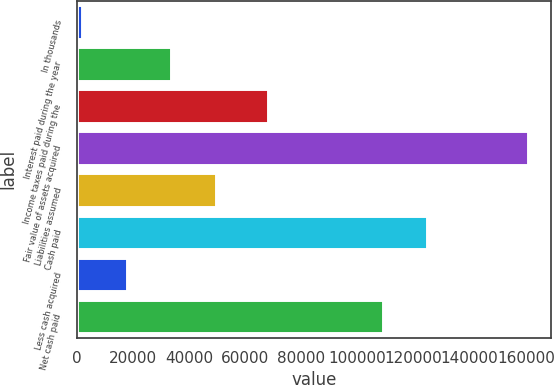<chart> <loc_0><loc_0><loc_500><loc_500><bar_chart><fcel>In thousands<fcel>Interest paid during the year<fcel>Income taxes paid during the<fcel>Fair value of assets acquired<fcel>Liabilities assumed<fcel>Cash paid<fcel>Less cash acquired<fcel>Net cash paid<nl><fcel>2011<fcel>33781.2<fcel>68053<fcel>160862<fcel>49666.3<fcel>124879<fcel>17896.1<fcel>108994<nl></chart> 